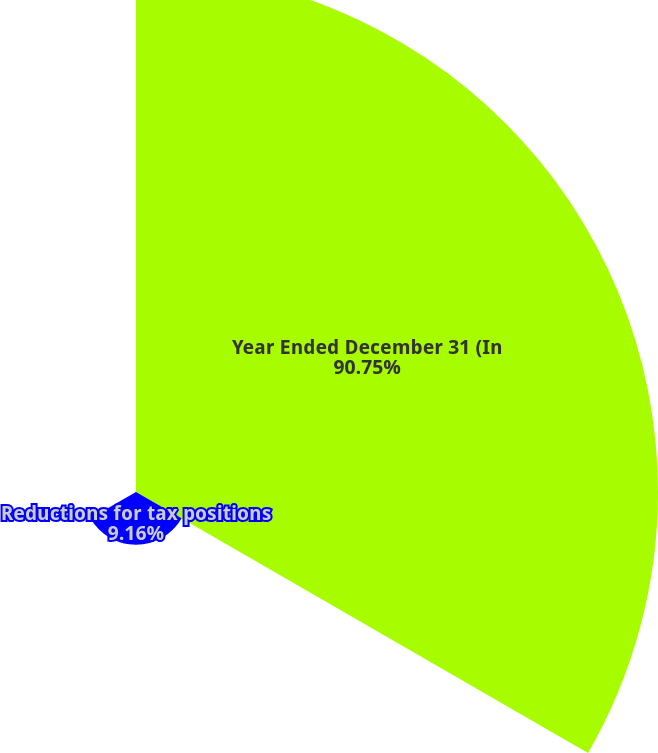<chart> <loc_0><loc_0><loc_500><loc_500><pie_chart><fcel>Year Ended December 31 (In<fcel>Reductions for tax positions<fcel>Lapse of statute of<nl><fcel>90.75%<fcel>9.16%<fcel>0.09%<nl></chart> 